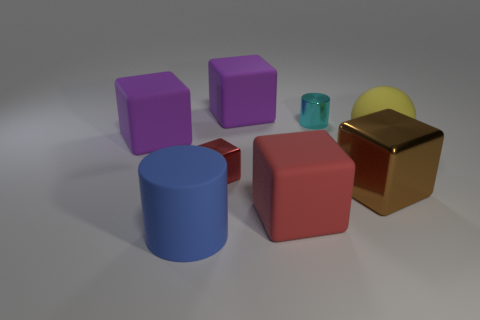Are there any red blocks of the same size as the metal cylinder?
Your response must be concise. Yes. Are there any objects of the same color as the tiny block?
Ensure brevity in your answer.  Yes. What number of rubber cubes are the same color as the shiny cylinder?
Your response must be concise. 0. There is a tiny cube; is its color the same as the large rubber cube that is in front of the small metallic block?
Ensure brevity in your answer.  Yes. How many objects are tiny shiny objects or purple matte blocks that are behind the rubber sphere?
Give a very brief answer. 4. There is a rubber thing behind the big block to the left of the big blue rubber cylinder; how big is it?
Give a very brief answer. Large. Are there an equal number of big blue matte cylinders on the right side of the large red rubber block and yellow matte balls in front of the large yellow rubber sphere?
Your answer should be very brief. Yes. Are there any metallic blocks on the left side of the block that is in front of the big metal cube?
Give a very brief answer. Yes. The large blue thing that is made of the same material as the yellow object is what shape?
Your answer should be compact. Cylinder. Is there anything else that is the same color as the matte sphere?
Ensure brevity in your answer.  No. 